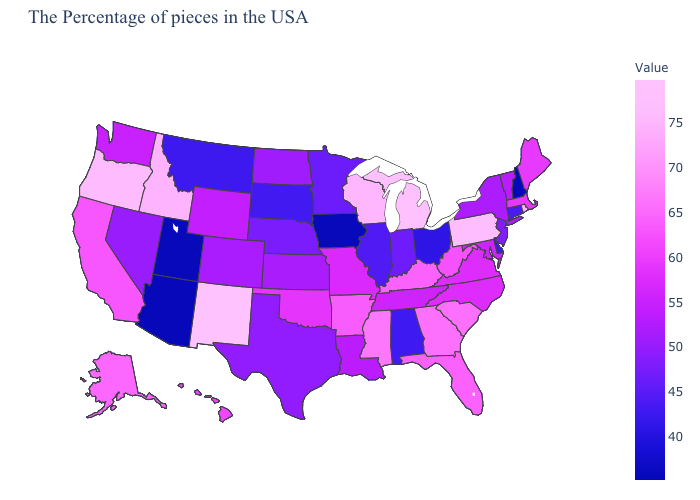Does the map have missing data?
Short answer required. No. Does Mississippi have the highest value in the South?
Keep it brief. Yes. Among the states that border Georgia , which have the highest value?
Write a very short answer. South Carolina. Does New Hampshire have the lowest value in the USA?
Quick response, please. Yes. 